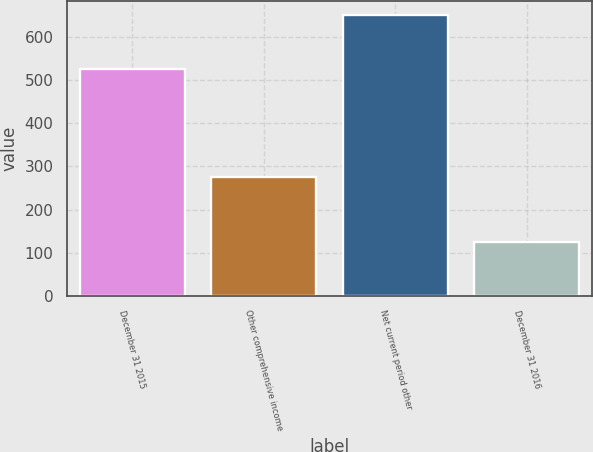Convert chart. <chart><loc_0><loc_0><loc_500><loc_500><bar_chart><fcel>December 31 2015<fcel>Other comprehensive income<fcel>Net current period other<fcel>December 31 2016<nl><fcel>526<fcel>276<fcel>650<fcel>124<nl></chart> 